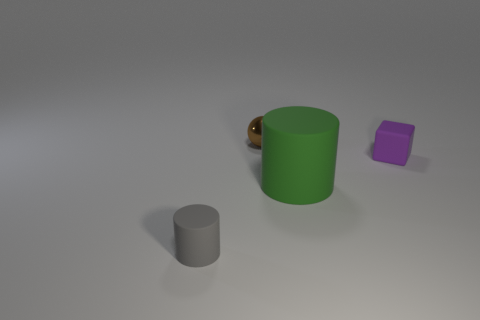Add 3 cyan matte balls. How many objects exist? 7 Subtract all spheres. How many objects are left? 3 Subtract all big rubber balls. Subtract all big green objects. How many objects are left? 3 Add 4 large green rubber cylinders. How many large green rubber cylinders are left? 5 Add 4 green rubber objects. How many green rubber objects exist? 5 Subtract 0 cyan blocks. How many objects are left? 4 